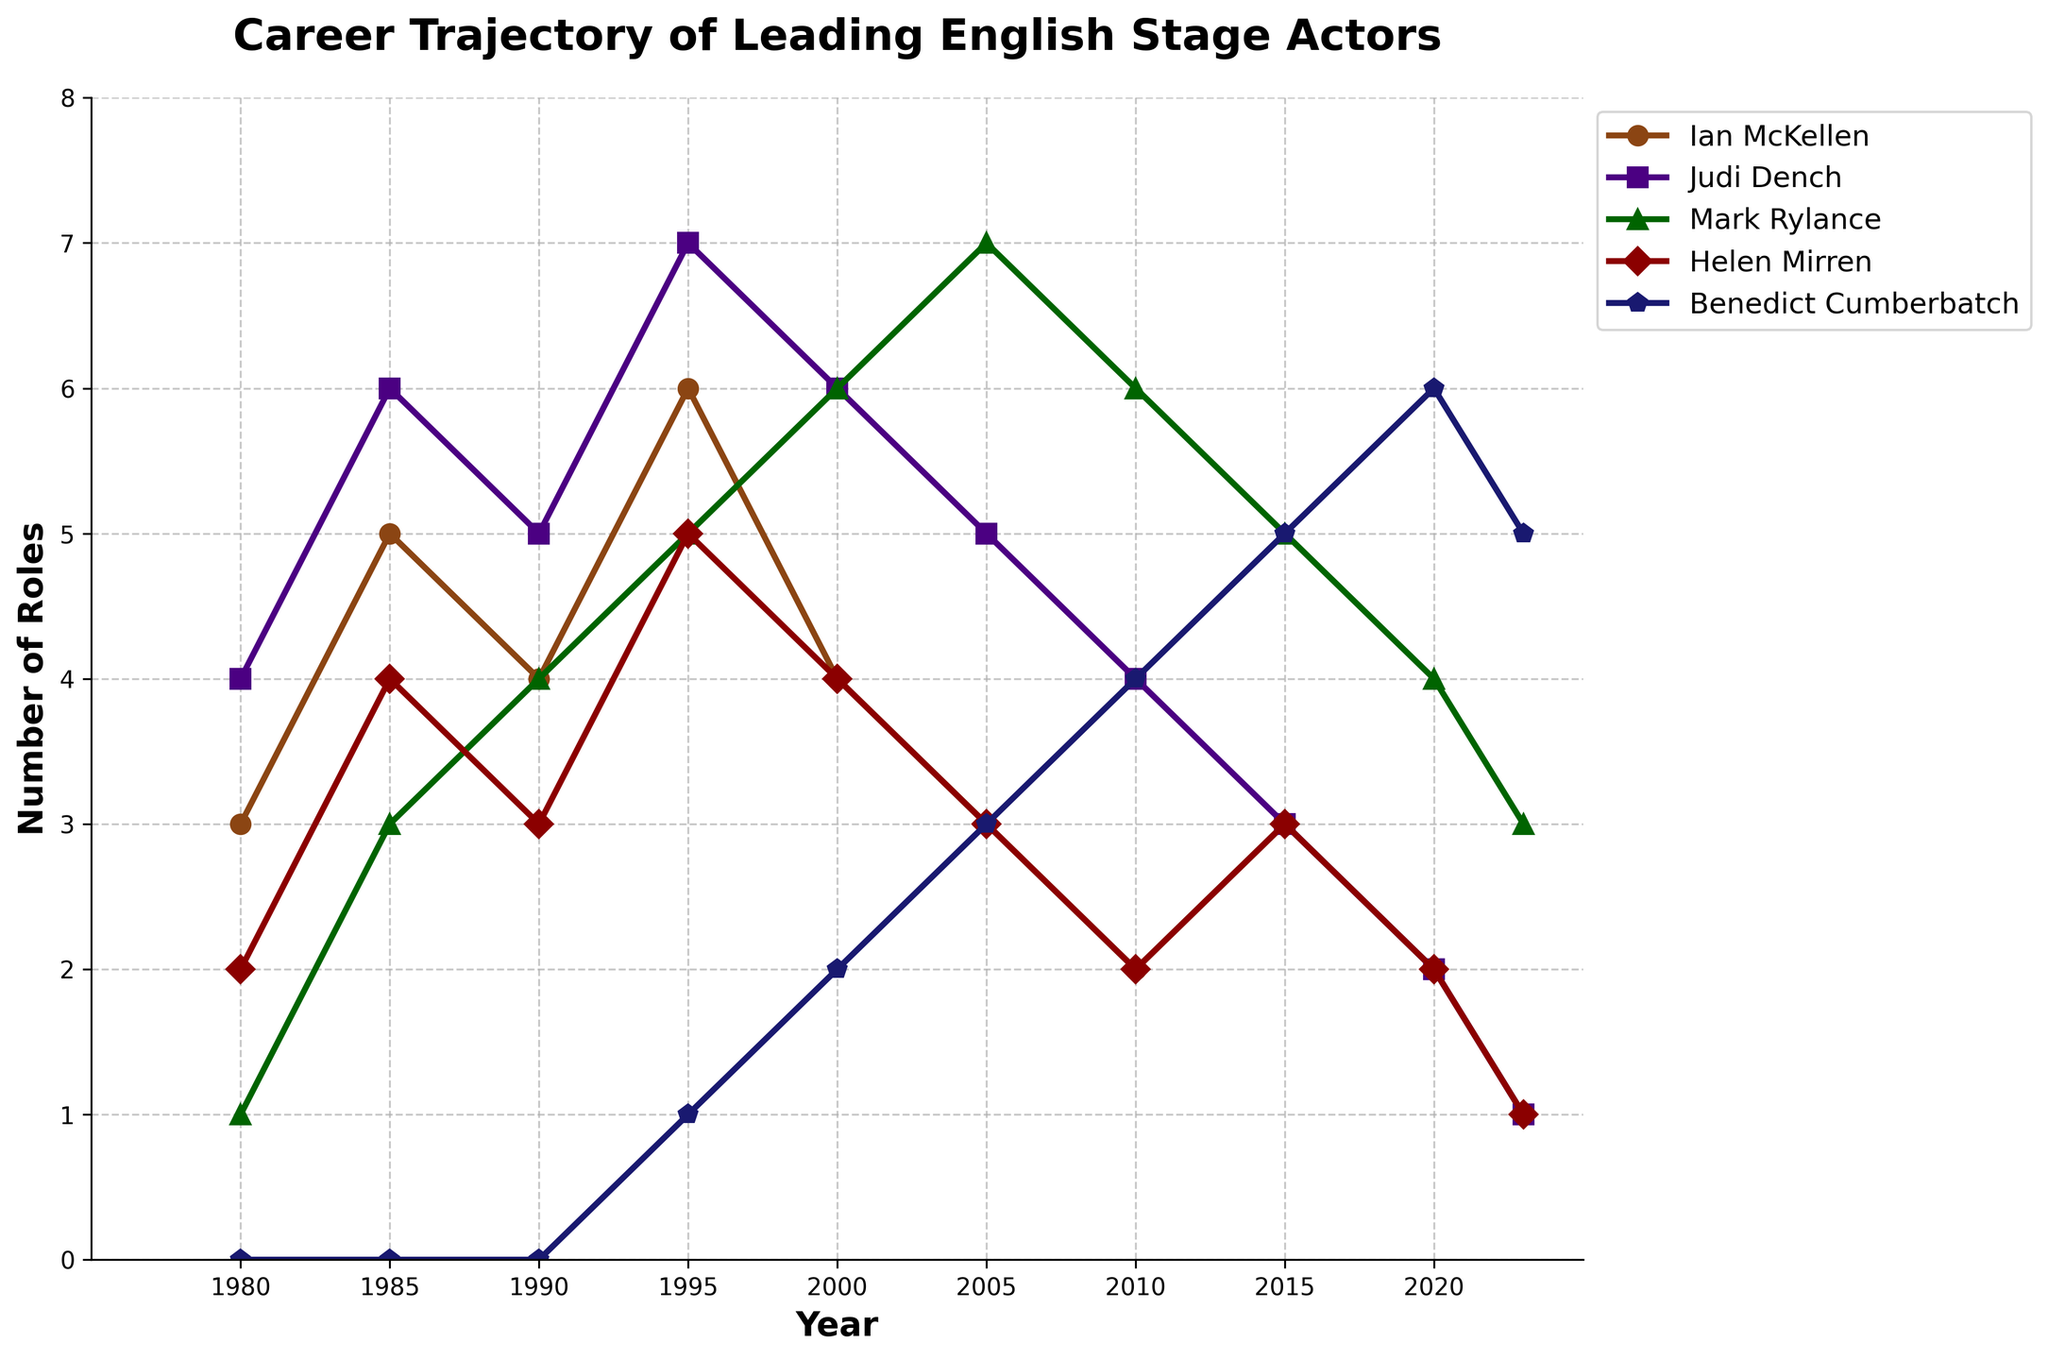Which actor had the highest number of roles in 1995? Look at the values for 1995: Ian McKellen (6), Judi Dench (7), Mark Rylance (5), Helen Mirren (5), Benedict Cumberbatch (1). Judi Dench has the highest number with 7 roles.
Answer: Judi Dench How did the number of roles for Benedict Cumberbatch change from 2000 to 2023? Benedict Cumberbatch had 2 roles in 2000 and 5 roles in 2023. The change is 5 - 2 = 3 roles.
Answer: Increased by 3 Which two actors had the same number of roles in 2010, and what was the number? Look at the values for 2010: Ian McKellen (2), Judi Dench (4), Mark Rylance (6), Helen Mirren (2), Benedict Cumberbatch (4). Ian McKellen and Helen Mirren both had 2 roles.
Answer: Ian McKellen and Helen Mirren, 2 roles Compare the career trajectories of Judi Dench and Mark Rylance from 1980 to 2023. Who had a generally increasing trend? Observe the overall trend for both actors from 1980 to 2023. Judi Dench’s roles peak around the mid-1990s and decrease afterward. Mark Rylance’s roles generally increase over time.
Answer: Mark Rylance What is the difference in the number of roles played by Ian McKellen and Helen Mirren in the year 2020? Ian McKellen had 2 roles and Helen Mirren had 2 roles in 2020. The difference is 2 - 2 = 0 roles.
Answer: 0 Which actor showed the greatest decrease in the number of roles from their peak year? Find the peak year and number of roles for each actor, then find the lowest value thereafter. Ian McKellen peaked at 6 roles in 1995 and dropped to 1 in 2023, a decrease of 5 roles.
Answer: Ian McKellen How many total roles did Helen Mirren perform from 2000 to 2010? Helen Mirren performed 4 roles in 2000, 3 roles in 2005, and 2 roles in 2010. The sum is 4 + 3 + 2 = 9 roles.
Answer: 9 Between 1995 and 2023, which actor had the smallest change in the number of roles performed, and what was the change? Consider the roles for 1995 and 2023: Ian McKellen (6 to 1, change is 5), Judi Dench (7 to 1, change is 6), Mark Rylance (5 to 3, change is 2), Helen Mirren (5 to 1, change is 4), Benedict Cumberbatch (1 to 5, change is 4). The smallest change is for Mark Rylance, with a change of 2.
Answer: Mark Rylance, change of 2 What was the average number of roles performed by all the actors in 1985? The roles in 1985 are: Ian McKellen (5), Judi Dench (6), Mark Rylance (3), Helen Mirren (4), Benedict Cumberbatch (0). The average is (5 + 6 + 3 + 4 + 0) / 5 = 18 / 5 = 3.6.
Answer: 3.6 Which actor had roles in all the years shown? Observe each actor’s data points from 1980 to 2023. Mark Rylance is the only actor with roles in every year listed.
Answer: Mark Rylance 